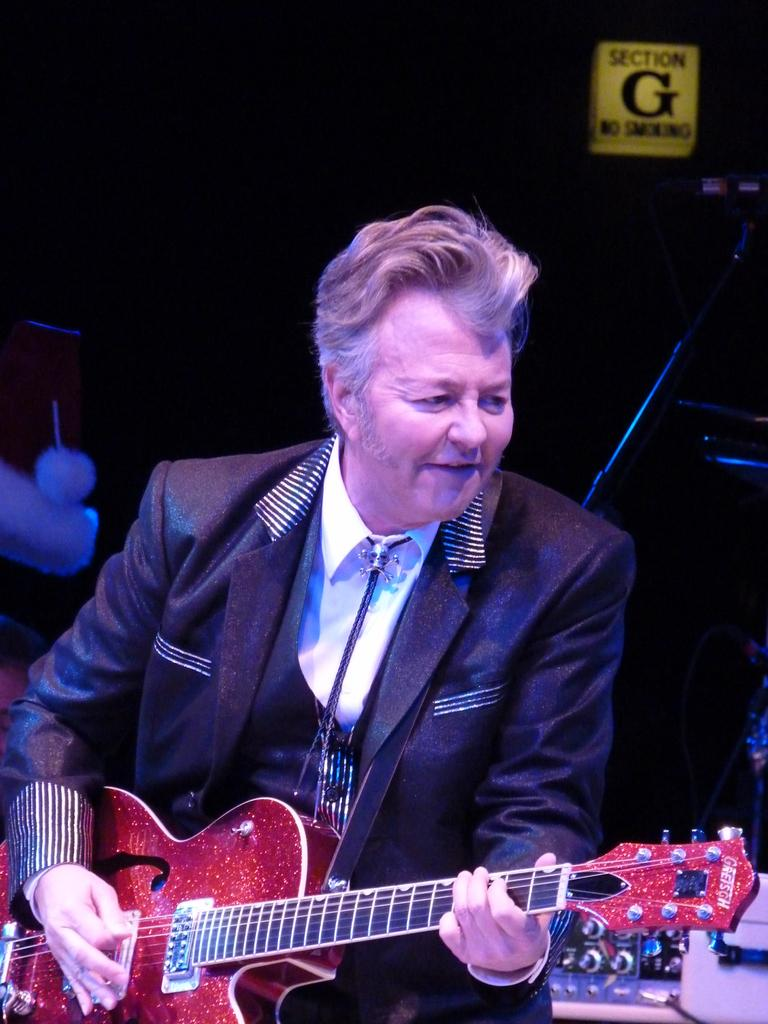What is the man in the image doing? The man is playing the guitar. What is the man holding in the image? The man is holding a guitar. What is the man's facial expression in the image? The man is smiling. What can be observed about the background of the image? The background of the image is dark. How many robins are perched on the guitar in the image? There are no robins present in the image. What type of carpenter is the man in the image? The image does not provide any information about the man being a carpenter. 